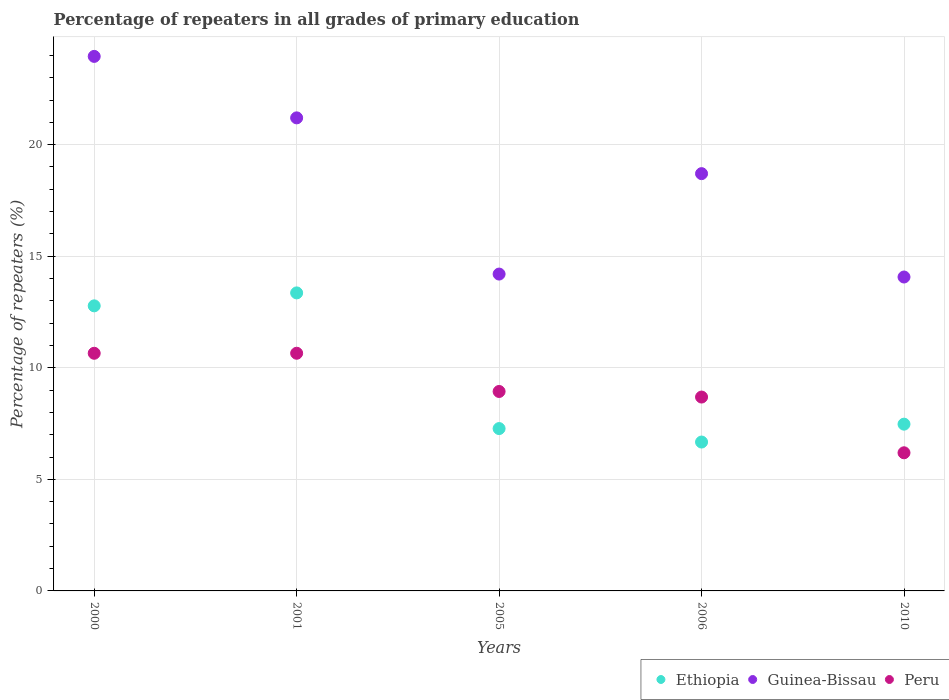What is the percentage of repeaters in Peru in 2001?
Offer a terse response. 10.65. Across all years, what is the maximum percentage of repeaters in Guinea-Bissau?
Keep it short and to the point. 23.95. Across all years, what is the minimum percentage of repeaters in Guinea-Bissau?
Your answer should be compact. 14.07. In which year was the percentage of repeaters in Peru minimum?
Keep it short and to the point. 2010. What is the total percentage of repeaters in Guinea-Bissau in the graph?
Provide a succinct answer. 92.12. What is the difference between the percentage of repeaters in Peru in 2001 and that in 2006?
Your answer should be compact. 1.96. What is the difference between the percentage of repeaters in Ethiopia in 2001 and the percentage of repeaters in Guinea-Bissau in 2010?
Your answer should be very brief. -0.71. What is the average percentage of repeaters in Guinea-Bissau per year?
Ensure brevity in your answer.  18.42. In the year 2010, what is the difference between the percentage of repeaters in Guinea-Bissau and percentage of repeaters in Ethiopia?
Ensure brevity in your answer.  6.59. What is the ratio of the percentage of repeaters in Ethiopia in 2000 to that in 2005?
Your response must be concise. 1.76. Is the difference between the percentage of repeaters in Guinea-Bissau in 2005 and 2006 greater than the difference between the percentage of repeaters in Ethiopia in 2005 and 2006?
Ensure brevity in your answer.  No. What is the difference between the highest and the second highest percentage of repeaters in Guinea-Bissau?
Provide a short and direct response. 2.75. What is the difference between the highest and the lowest percentage of repeaters in Guinea-Bissau?
Make the answer very short. 9.89. Is it the case that in every year, the sum of the percentage of repeaters in Guinea-Bissau and percentage of repeaters in Peru  is greater than the percentage of repeaters in Ethiopia?
Keep it short and to the point. Yes. How many dotlines are there?
Provide a short and direct response. 3. How many years are there in the graph?
Your answer should be very brief. 5. What is the difference between two consecutive major ticks on the Y-axis?
Your answer should be very brief. 5. Where does the legend appear in the graph?
Offer a terse response. Bottom right. How are the legend labels stacked?
Keep it short and to the point. Horizontal. What is the title of the graph?
Offer a very short reply. Percentage of repeaters in all grades of primary education. What is the label or title of the X-axis?
Give a very brief answer. Years. What is the label or title of the Y-axis?
Provide a succinct answer. Percentage of repeaters (%). What is the Percentage of repeaters (%) in Ethiopia in 2000?
Give a very brief answer. 12.78. What is the Percentage of repeaters (%) in Guinea-Bissau in 2000?
Offer a very short reply. 23.95. What is the Percentage of repeaters (%) of Peru in 2000?
Your answer should be very brief. 10.65. What is the Percentage of repeaters (%) of Ethiopia in 2001?
Offer a very short reply. 13.36. What is the Percentage of repeaters (%) in Guinea-Bissau in 2001?
Provide a short and direct response. 21.2. What is the Percentage of repeaters (%) in Peru in 2001?
Make the answer very short. 10.65. What is the Percentage of repeaters (%) in Ethiopia in 2005?
Keep it short and to the point. 7.28. What is the Percentage of repeaters (%) in Guinea-Bissau in 2005?
Give a very brief answer. 14.2. What is the Percentage of repeaters (%) in Peru in 2005?
Your response must be concise. 8.94. What is the Percentage of repeaters (%) in Ethiopia in 2006?
Offer a terse response. 6.67. What is the Percentage of repeaters (%) in Guinea-Bissau in 2006?
Ensure brevity in your answer.  18.7. What is the Percentage of repeaters (%) of Peru in 2006?
Keep it short and to the point. 8.69. What is the Percentage of repeaters (%) in Ethiopia in 2010?
Keep it short and to the point. 7.47. What is the Percentage of repeaters (%) in Guinea-Bissau in 2010?
Your answer should be very brief. 14.07. What is the Percentage of repeaters (%) in Peru in 2010?
Provide a short and direct response. 6.19. Across all years, what is the maximum Percentage of repeaters (%) of Ethiopia?
Make the answer very short. 13.36. Across all years, what is the maximum Percentage of repeaters (%) of Guinea-Bissau?
Provide a succinct answer. 23.95. Across all years, what is the maximum Percentage of repeaters (%) of Peru?
Make the answer very short. 10.65. Across all years, what is the minimum Percentage of repeaters (%) in Ethiopia?
Ensure brevity in your answer.  6.67. Across all years, what is the minimum Percentage of repeaters (%) of Guinea-Bissau?
Your response must be concise. 14.07. Across all years, what is the minimum Percentage of repeaters (%) of Peru?
Your answer should be very brief. 6.19. What is the total Percentage of repeaters (%) in Ethiopia in the graph?
Make the answer very short. 47.55. What is the total Percentage of repeaters (%) of Guinea-Bissau in the graph?
Provide a succinct answer. 92.12. What is the total Percentage of repeaters (%) of Peru in the graph?
Provide a succinct answer. 45.12. What is the difference between the Percentage of repeaters (%) in Ethiopia in 2000 and that in 2001?
Offer a terse response. -0.58. What is the difference between the Percentage of repeaters (%) in Guinea-Bissau in 2000 and that in 2001?
Provide a succinct answer. 2.75. What is the difference between the Percentage of repeaters (%) in Peru in 2000 and that in 2001?
Provide a succinct answer. -0. What is the difference between the Percentage of repeaters (%) in Guinea-Bissau in 2000 and that in 2005?
Provide a succinct answer. 9.75. What is the difference between the Percentage of repeaters (%) of Peru in 2000 and that in 2005?
Provide a succinct answer. 1.71. What is the difference between the Percentage of repeaters (%) of Ethiopia in 2000 and that in 2006?
Make the answer very short. 6.1. What is the difference between the Percentage of repeaters (%) in Guinea-Bissau in 2000 and that in 2006?
Provide a succinct answer. 5.25. What is the difference between the Percentage of repeaters (%) in Peru in 2000 and that in 2006?
Make the answer very short. 1.96. What is the difference between the Percentage of repeaters (%) of Ethiopia in 2000 and that in 2010?
Your response must be concise. 5.3. What is the difference between the Percentage of repeaters (%) of Guinea-Bissau in 2000 and that in 2010?
Your response must be concise. 9.89. What is the difference between the Percentage of repeaters (%) of Peru in 2000 and that in 2010?
Ensure brevity in your answer.  4.46. What is the difference between the Percentage of repeaters (%) of Ethiopia in 2001 and that in 2005?
Provide a succinct answer. 6.08. What is the difference between the Percentage of repeaters (%) in Guinea-Bissau in 2001 and that in 2005?
Your answer should be very brief. 7. What is the difference between the Percentage of repeaters (%) of Peru in 2001 and that in 2005?
Provide a short and direct response. 1.71. What is the difference between the Percentage of repeaters (%) of Ethiopia in 2001 and that in 2006?
Your answer should be very brief. 6.68. What is the difference between the Percentage of repeaters (%) of Peru in 2001 and that in 2006?
Make the answer very short. 1.96. What is the difference between the Percentage of repeaters (%) in Ethiopia in 2001 and that in 2010?
Your answer should be very brief. 5.88. What is the difference between the Percentage of repeaters (%) of Guinea-Bissau in 2001 and that in 2010?
Give a very brief answer. 7.13. What is the difference between the Percentage of repeaters (%) in Peru in 2001 and that in 2010?
Provide a succinct answer. 4.46. What is the difference between the Percentage of repeaters (%) in Ethiopia in 2005 and that in 2006?
Ensure brevity in your answer.  0.6. What is the difference between the Percentage of repeaters (%) of Guinea-Bissau in 2005 and that in 2006?
Provide a short and direct response. -4.5. What is the difference between the Percentage of repeaters (%) in Peru in 2005 and that in 2006?
Provide a succinct answer. 0.25. What is the difference between the Percentage of repeaters (%) in Ethiopia in 2005 and that in 2010?
Give a very brief answer. -0.2. What is the difference between the Percentage of repeaters (%) in Guinea-Bissau in 2005 and that in 2010?
Make the answer very short. 0.13. What is the difference between the Percentage of repeaters (%) of Peru in 2005 and that in 2010?
Offer a terse response. 2.75. What is the difference between the Percentage of repeaters (%) of Ethiopia in 2006 and that in 2010?
Your answer should be compact. -0.8. What is the difference between the Percentage of repeaters (%) of Guinea-Bissau in 2006 and that in 2010?
Offer a very short reply. 4.63. What is the difference between the Percentage of repeaters (%) in Peru in 2006 and that in 2010?
Offer a very short reply. 2.5. What is the difference between the Percentage of repeaters (%) in Ethiopia in 2000 and the Percentage of repeaters (%) in Guinea-Bissau in 2001?
Keep it short and to the point. -8.42. What is the difference between the Percentage of repeaters (%) in Ethiopia in 2000 and the Percentage of repeaters (%) in Peru in 2001?
Your answer should be very brief. 2.12. What is the difference between the Percentage of repeaters (%) in Guinea-Bissau in 2000 and the Percentage of repeaters (%) in Peru in 2001?
Your answer should be compact. 13.3. What is the difference between the Percentage of repeaters (%) in Ethiopia in 2000 and the Percentage of repeaters (%) in Guinea-Bissau in 2005?
Your response must be concise. -1.42. What is the difference between the Percentage of repeaters (%) of Ethiopia in 2000 and the Percentage of repeaters (%) of Peru in 2005?
Your answer should be compact. 3.84. What is the difference between the Percentage of repeaters (%) of Guinea-Bissau in 2000 and the Percentage of repeaters (%) of Peru in 2005?
Give a very brief answer. 15.02. What is the difference between the Percentage of repeaters (%) of Ethiopia in 2000 and the Percentage of repeaters (%) of Guinea-Bissau in 2006?
Your answer should be very brief. -5.92. What is the difference between the Percentage of repeaters (%) in Ethiopia in 2000 and the Percentage of repeaters (%) in Peru in 2006?
Offer a very short reply. 4.09. What is the difference between the Percentage of repeaters (%) of Guinea-Bissau in 2000 and the Percentage of repeaters (%) of Peru in 2006?
Provide a succinct answer. 15.27. What is the difference between the Percentage of repeaters (%) of Ethiopia in 2000 and the Percentage of repeaters (%) of Guinea-Bissau in 2010?
Offer a terse response. -1.29. What is the difference between the Percentage of repeaters (%) of Ethiopia in 2000 and the Percentage of repeaters (%) of Peru in 2010?
Provide a succinct answer. 6.59. What is the difference between the Percentage of repeaters (%) in Guinea-Bissau in 2000 and the Percentage of repeaters (%) in Peru in 2010?
Your answer should be compact. 17.76. What is the difference between the Percentage of repeaters (%) of Ethiopia in 2001 and the Percentage of repeaters (%) of Guinea-Bissau in 2005?
Keep it short and to the point. -0.84. What is the difference between the Percentage of repeaters (%) of Ethiopia in 2001 and the Percentage of repeaters (%) of Peru in 2005?
Provide a short and direct response. 4.42. What is the difference between the Percentage of repeaters (%) in Guinea-Bissau in 2001 and the Percentage of repeaters (%) in Peru in 2005?
Your response must be concise. 12.26. What is the difference between the Percentage of repeaters (%) in Ethiopia in 2001 and the Percentage of repeaters (%) in Guinea-Bissau in 2006?
Your answer should be compact. -5.34. What is the difference between the Percentage of repeaters (%) of Ethiopia in 2001 and the Percentage of repeaters (%) of Peru in 2006?
Make the answer very short. 4.67. What is the difference between the Percentage of repeaters (%) in Guinea-Bissau in 2001 and the Percentage of repeaters (%) in Peru in 2006?
Your answer should be very brief. 12.51. What is the difference between the Percentage of repeaters (%) of Ethiopia in 2001 and the Percentage of repeaters (%) of Guinea-Bissau in 2010?
Your answer should be very brief. -0.71. What is the difference between the Percentage of repeaters (%) of Ethiopia in 2001 and the Percentage of repeaters (%) of Peru in 2010?
Your answer should be very brief. 7.17. What is the difference between the Percentage of repeaters (%) of Guinea-Bissau in 2001 and the Percentage of repeaters (%) of Peru in 2010?
Provide a succinct answer. 15.01. What is the difference between the Percentage of repeaters (%) in Ethiopia in 2005 and the Percentage of repeaters (%) in Guinea-Bissau in 2006?
Keep it short and to the point. -11.42. What is the difference between the Percentage of repeaters (%) of Ethiopia in 2005 and the Percentage of repeaters (%) of Peru in 2006?
Provide a succinct answer. -1.41. What is the difference between the Percentage of repeaters (%) in Guinea-Bissau in 2005 and the Percentage of repeaters (%) in Peru in 2006?
Make the answer very short. 5.51. What is the difference between the Percentage of repeaters (%) in Ethiopia in 2005 and the Percentage of repeaters (%) in Guinea-Bissau in 2010?
Provide a succinct answer. -6.79. What is the difference between the Percentage of repeaters (%) in Ethiopia in 2005 and the Percentage of repeaters (%) in Peru in 2010?
Provide a short and direct response. 1.09. What is the difference between the Percentage of repeaters (%) in Guinea-Bissau in 2005 and the Percentage of repeaters (%) in Peru in 2010?
Ensure brevity in your answer.  8.01. What is the difference between the Percentage of repeaters (%) of Ethiopia in 2006 and the Percentage of repeaters (%) of Guinea-Bissau in 2010?
Give a very brief answer. -7.4. What is the difference between the Percentage of repeaters (%) in Ethiopia in 2006 and the Percentage of repeaters (%) in Peru in 2010?
Your answer should be compact. 0.48. What is the difference between the Percentage of repeaters (%) in Guinea-Bissau in 2006 and the Percentage of repeaters (%) in Peru in 2010?
Offer a very short reply. 12.51. What is the average Percentage of repeaters (%) in Ethiopia per year?
Give a very brief answer. 9.51. What is the average Percentage of repeaters (%) in Guinea-Bissau per year?
Offer a very short reply. 18.42. What is the average Percentage of repeaters (%) in Peru per year?
Offer a terse response. 9.02. In the year 2000, what is the difference between the Percentage of repeaters (%) in Ethiopia and Percentage of repeaters (%) in Guinea-Bissau?
Your answer should be compact. -11.18. In the year 2000, what is the difference between the Percentage of repeaters (%) of Ethiopia and Percentage of repeaters (%) of Peru?
Make the answer very short. 2.13. In the year 2000, what is the difference between the Percentage of repeaters (%) in Guinea-Bissau and Percentage of repeaters (%) in Peru?
Keep it short and to the point. 13.3. In the year 2001, what is the difference between the Percentage of repeaters (%) of Ethiopia and Percentage of repeaters (%) of Guinea-Bissau?
Your answer should be compact. -7.84. In the year 2001, what is the difference between the Percentage of repeaters (%) in Ethiopia and Percentage of repeaters (%) in Peru?
Your answer should be very brief. 2.7. In the year 2001, what is the difference between the Percentage of repeaters (%) of Guinea-Bissau and Percentage of repeaters (%) of Peru?
Give a very brief answer. 10.55. In the year 2005, what is the difference between the Percentage of repeaters (%) in Ethiopia and Percentage of repeaters (%) in Guinea-Bissau?
Ensure brevity in your answer.  -6.92. In the year 2005, what is the difference between the Percentage of repeaters (%) of Ethiopia and Percentage of repeaters (%) of Peru?
Make the answer very short. -1.66. In the year 2005, what is the difference between the Percentage of repeaters (%) of Guinea-Bissau and Percentage of repeaters (%) of Peru?
Provide a short and direct response. 5.26. In the year 2006, what is the difference between the Percentage of repeaters (%) of Ethiopia and Percentage of repeaters (%) of Guinea-Bissau?
Make the answer very short. -12.03. In the year 2006, what is the difference between the Percentage of repeaters (%) of Ethiopia and Percentage of repeaters (%) of Peru?
Offer a terse response. -2.02. In the year 2006, what is the difference between the Percentage of repeaters (%) in Guinea-Bissau and Percentage of repeaters (%) in Peru?
Keep it short and to the point. 10.01. In the year 2010, what is the difference between the Percentage of repeaters (%) in Ethiopia and Percentage of repeaters (%) in Guinea-Bissau?
Your answer should be very brief. -6.59. In the year 2010, what is the difference between the Percentage of repeaters (%) of Ethiopia and Percentage of repeaters (%) of Peru?
Provide a short and direct response. 1.28. In the year 2010, what is the difference between the Percentage of repeaters (%) of Guinea-Bissau and Percentage of repeaters (%) of Peru?
Ensure brevity in your answer.  7.88. What is the ratio of the Percentage of repeaters (%) of Ethiopia in 2000 to that in 2001?
Your answer should be compact. 0.96. What is the ratio of the Percentage of repeaters (%) of Guinea-Bissau in 2000 to that in 2001?
Provide a succinct answer. 1.13. What is the ratio of the Percentage of repeaters (%) in Peru in 2000 to that in 2001?
Your response must be concise. 1. What is the ratio of the Percentage of repeaters (%) of Ethiopia in 2000 to that in 2005?
Keep it short and to the point. 1.76. What is the ratio of the Percentage of repeaters (%) of Guinea-Bissau in 2000 to that in 2005?
Offer a very short reply. 1.69. What is the ratio of the Percentage of repeaters (%) of Peru in 2000 to that in 2005?
Make the answer very short. 1.19. What is the ratio of the Percentage of repeaters (%) in Ethiopia in 2000 to that in 2006?
Make the answer very short. 1.91. What is the ratio of the Percentage of repeaters (%) of Guinea-Bissau in 2000 to that in 2006?
Provide a succinct answer. 1.28. What is the ratio of the Percentage of repeaters (%) of Peru in 2000 to that in 2006?
Make the answer very short. 1.23. What is the ratio of the Percentage of repeaters (%) in Ethiopia in 2000 to that in 2010?
Give a very brief answer. 1.71. What is the ratio of the Percentage of repeaters (%) of Guinea-Bissau in 2000 to that in 2010?
Your answer should be compact. 1.7. What is the ratio of the Percentage of repeaters (%) in Peru in 2000 to that in 2010?
Ensure brevity in your answer.  1.72. What is the ratio of the Percentage of repeaters (%) in Ethiopia in 2001 to that in 2005?
Ensure brevity in your answer.  1.84. What is the ratio of the Percentage of repeaters (%) of Guinea-Bissau in 2001 to that in 2005?
Provide a succinct answer. 1.49. What is the ratio of the Percentage of repeaters (%) of Peru in 2001 to that in 2005?
Give a very brief answer. 1.19. What is the ratio of the Percentage of repeaters (%) in Ethiopia in 2001 to that in 2006?
Your response must be concise. 2. What is the ratio of the Percentage of repeaters (%) in Guinea-Bissau in 2001 to that in 2006?
Make the answer very short. 1.13. What is the ratio of the Percentage of repeaters (%) of Peru in 2001 to that in 2006?
Your answer should be compact. 1.23. What is the ratio of the Percentage of repeaters (%) of Ethiopia in 2001 to that in 2010?
Provide a short and direct response. 1.79. What is the ratio of the Percentage of repeaters (%) of Guinea-Bissau in 2001 to that in 2010?
Provide a short and direct response. 1.51. What is the ratio of the Percentage of repeaters (%) in Peru in 2001 to that in 2010?
Offer a terse response. 1.72. What is the ratio of the Percentage of repeaters (%) in Ethiopia in 2005 to that in 2006?
Offer a terse response. 1.09. What is the ratio of the Percentage of repeaters (%) of Guinea-Bissau in 2005 to that in 2006?
Make the answer very short. 0.76. What is the ratio of the Percentage of repeaters (%) in Peru in 2005 to that in 2006?
Make the answer very short. 1.03. What is the ratio of the Percentage of repeaters (%) in Ethiopia in 2005 to that in 2010?
Give a very brief answer. 0.97. What is the ratio of the Percentage of repeaters (%) of Guinea-Bissau in 2005 to that in 2010?
Ensure brevity in your answer.  1.01. What is the ratio of the Percentage of repeaters (%) in Peru in 2005 to that in 2010?
Provide a succinct answer. 1.44. What is the ratio of the Percentage of repeaters (%) in Ethiopia in 2006 to that in 2010?
Give a very brief answer. 0.89. What is the ratio of the Percentage of repeaters (%) in Guinea-Bissau in 2006 to that in 2010?
Keep it short and to the point. 1.33. What is the ratio of the Percentage of repeaters (%) of Peru in 2006 to that in 2010?
Offer a very short reply. 1.4. What is the difference between the highest and the second highest Percentage of repeaters (%) of Ethiopia?
Your response must be concise. 0.58. What is the difference between the highest and the second highest Percentage of repeaters (%) of Guinea-Bissau?
Your response must be concise. 2.75. What is the difference between the highest and the second highest Percentage of repeaters (%) in Peru?
Your answer should be compact. 0. What is the difference between the highest and the lowest Percentage of repeaters (%) of Ethiopia?
Provide a short and direct response. 6.68. What is the difference between the highest and the lowest Percentage of repeaters (%) of Guinea-Bissau?
Your response must be concise. 9.89. What is the difference between the highest and the lowest Percentage of repeaters (%) of Peru?
Keep it short and to the point. 4.46. 